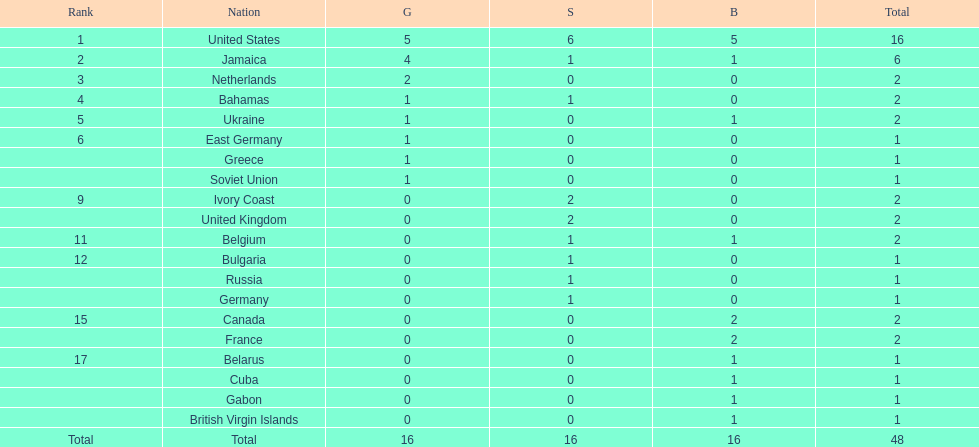What is the total number of gold medals won by jamaica? 4. 